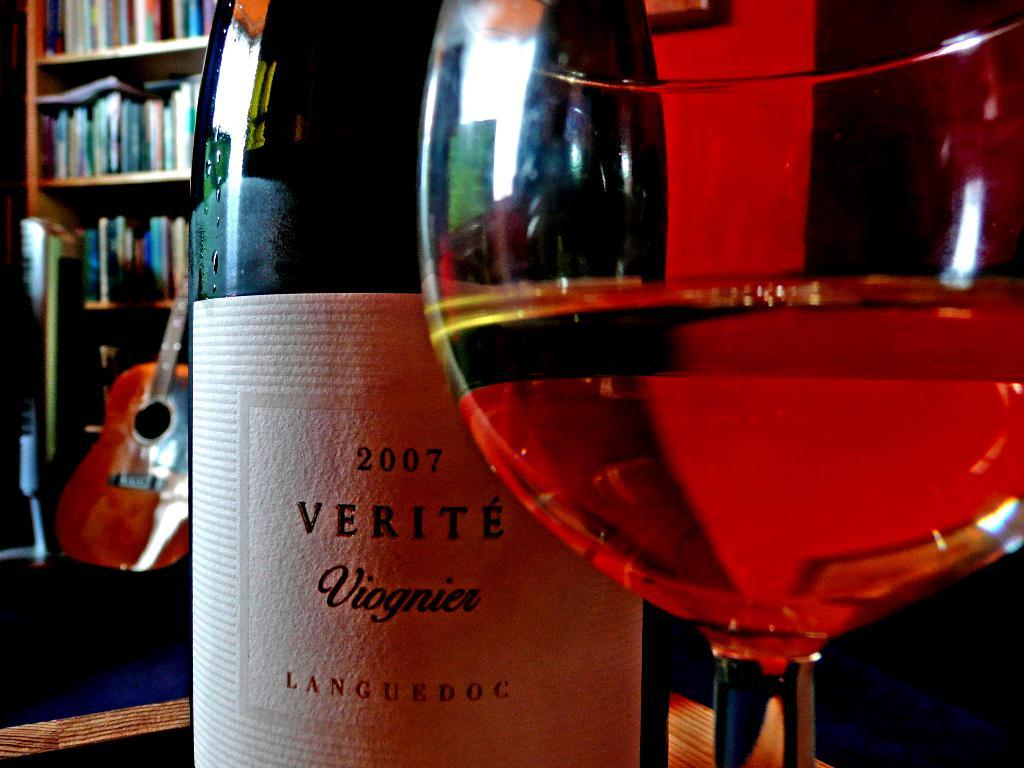<image>
Write a terse but informative summary of the picture. A bottle of Verite Viognier wine labeled 2007 